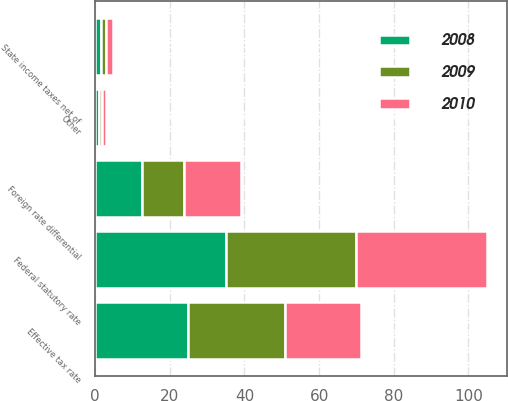<chart> <loc_0><loc_0><loc_500><loc_500><stacked_bar_chart><ecel><fcel>Federal statutory rate<fcel>State income taxes net of<fcel>Foreign rate differential<fcel>Other<fcel>Effective tax rate<nl><fcel>2010<fcel>35<fcel>1.9<fcel>15.3<fcel>1.1<fcel>20.5<nl><fcel>2008<fcel>35<fcel>1.5<fcel>12.5<fcel>1<fcel>25<nl><fcel>2009<fcel>35<fcel>1.3<fcel>11.4<fcel>0.9<fcel>25.8<nl></chart> 